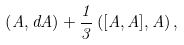Convert formula to latex. <formula><loc_0><loc_0><loc_500><loc_500>\left ( A , d A \right ) + \frac { 1 } { 3 } \left ( [ A , A ] , A \right ) ,</formula> 